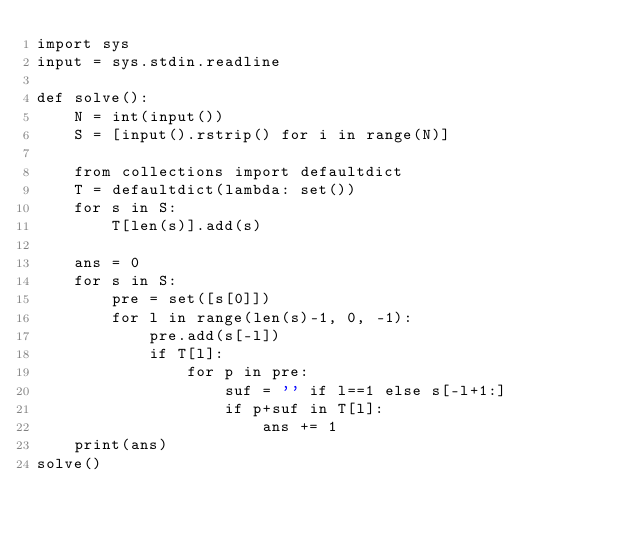Convert code to text. <code><loc_0><loc_0><loc_500><loc_500><_Python_>import sys
input = sys.stdin.readline

def solve():
    N = int(input())
    S = [input().rstrip() for i in range(N)]

    from collections import defaultdict
    T = defaultdict(lambda: set())
    for s in S:
        T[len(s)].add(s)

    ans = 0
    for s in S:
        pre = set([s[0]])
        for l in range(len(s)-1, 0, -1):
            pre.add(s[-l])
            if T[l]:
                for p in pre:
                    suf = '' if l==1 else s[-l+1:]
                    if p+suf in T[l]:
                        ans += 1
    print(ans)
solve()</code> 